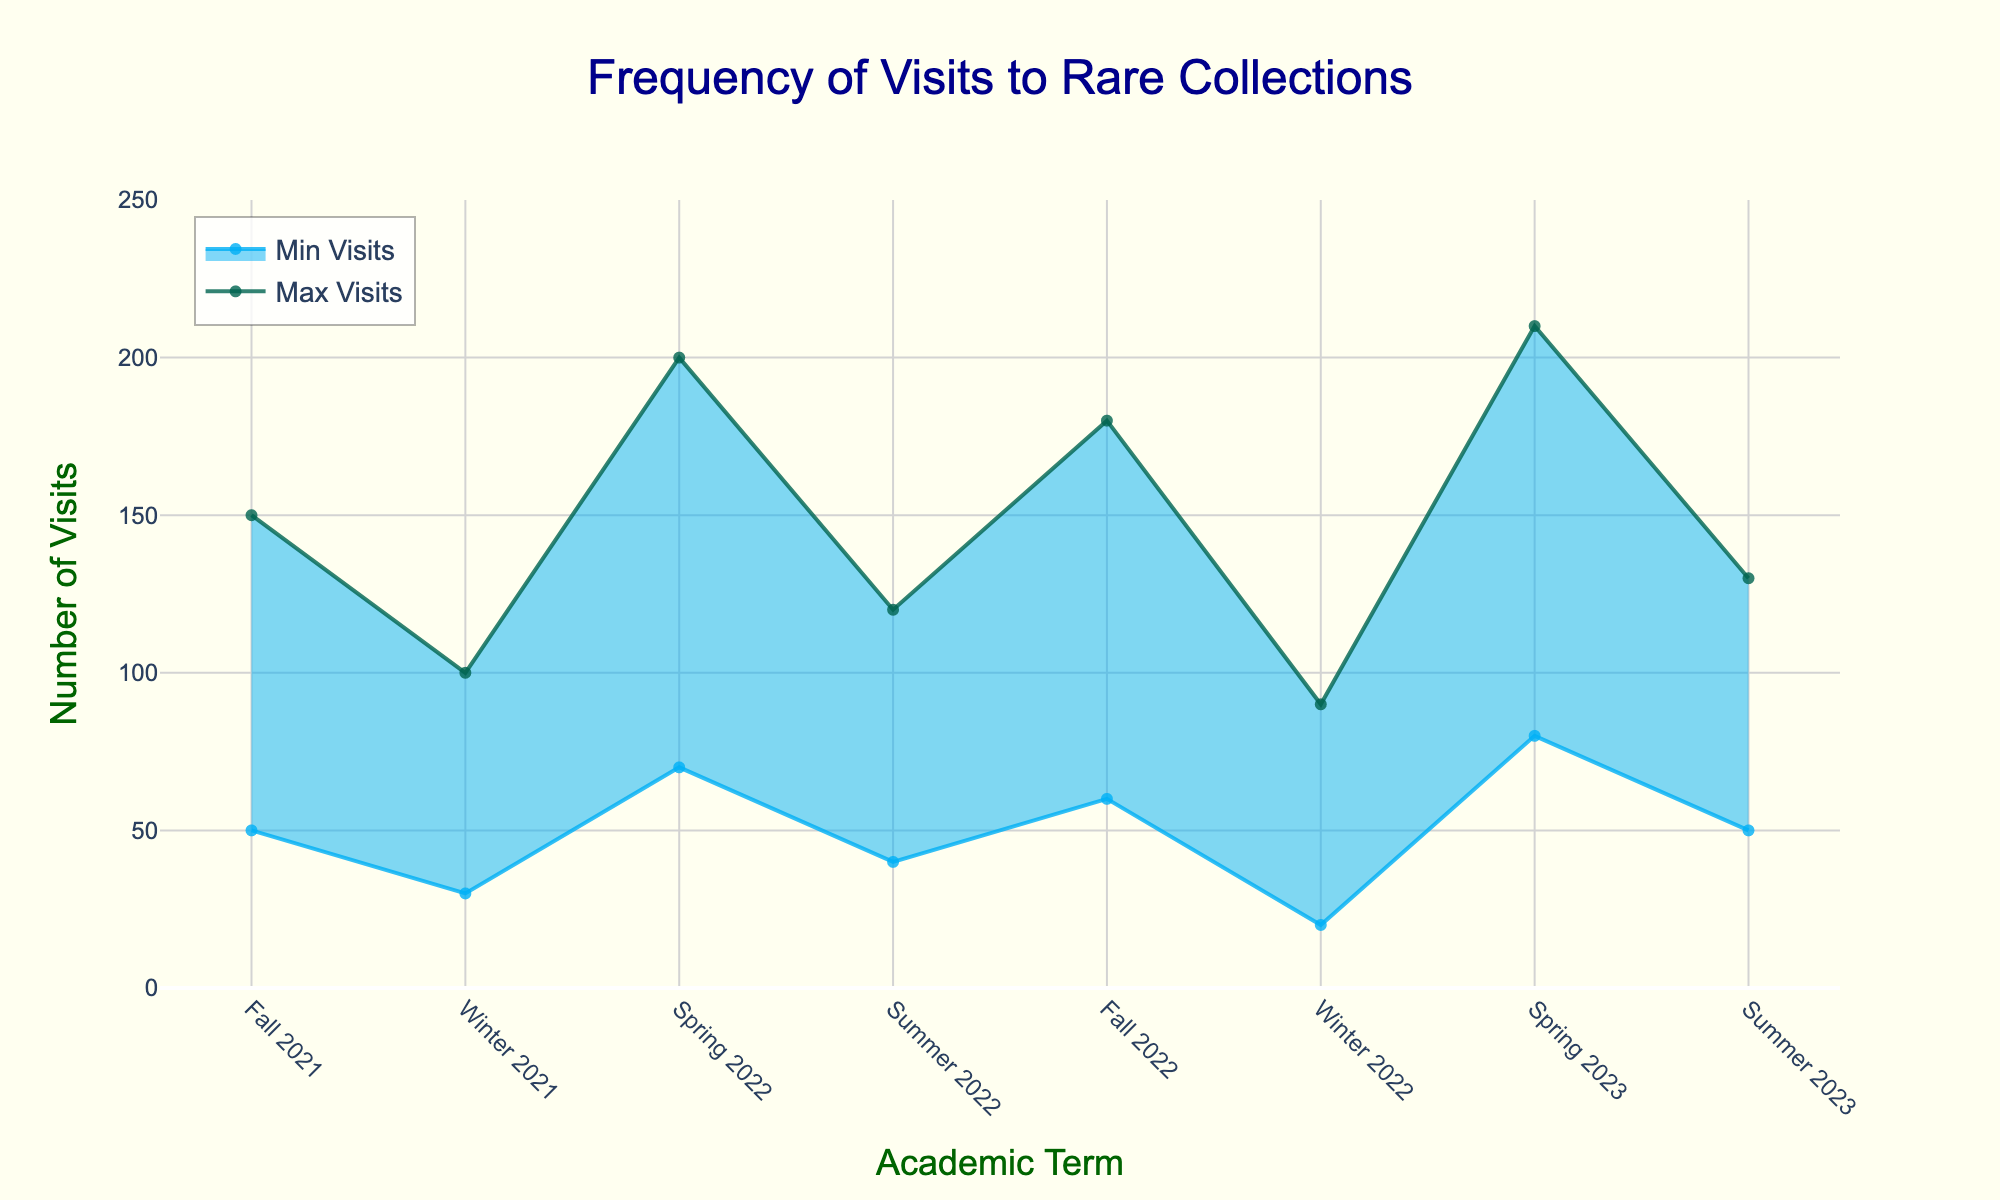what is the title of the chart? The title is located at the top of the chart and is typically a concise description of the visualized data. By reading the title area, we see that it is 'Frequency of Visits to Rare Collections'.
Answer: Frequency of Visits to Rare Collections What are the ranges of visits in Fall 2021? The range of visits is defined from the minimum to maximum values for that term. Looking at Fall 2021, the minimum is 50 and the maximum is 150.
Answer: 50 to 150 How many academic terms are represented in the chart? The academic terms are listed along the x-axis of the chart. Counting each unique term from Fall 2021 to Summer 2023, we see there are 8 academic terms.
Answer: 8 Which term has the highest minimum number of visits? Observing the lower end of each vertical band (representing minimum visits), Spring 2023 has the highest minimum number of visits, which is 80.
Answer: Spring 2023 What is the difference in the number of visits between the maximum value of Spring 2022 and the minimum value of Winter 2022? The maximum visits for Spring 2022 is 200, and the minimum visits for Winter 2022 is 20. The difference is calculated as 200 - 20 = 180.
Answer: 180 What is the average of the maximum visits over all terms? Summing the maximum visits for all terms (150 + 100 + 200 + 120 + 180 + 90 + 210 + 130) gives 1180. Dividing by the number of terms (8), the average is 1180 / 8 = 147.5.
Answer: 147.5 How does the max number of visits in Winter 2022 compare to that in Winter 2021? The chart shows that Winter 2021 has a maximum of 100 visits, while Winter 2022 has a maximum of 90 visits. Hence, Winter 2022 has 10 fewer visits than Winter 2021.
Answer: 10 fewer In which term did the number of visits increase both in the minimum and maximum values compared to the previous term? Reviewing the progression from term to term, both minimum and maximum increase from Winter 2021 (30, 100) to Spring 2022 (70, 200) and from Winter 2022 (20, 90) to Spring 2023 (80, 210). So, the terms are Spring 2022 and Spring 2023.
Answer: Spring 2022 and Spring 2023 Which term shows the smallest range between min and max visits? The range is calculated by subtracting the minimum value from the maximum value in each term. Winter 2022 has the smallest range of 70 (90 - 20).
Answer: Winter 2022 